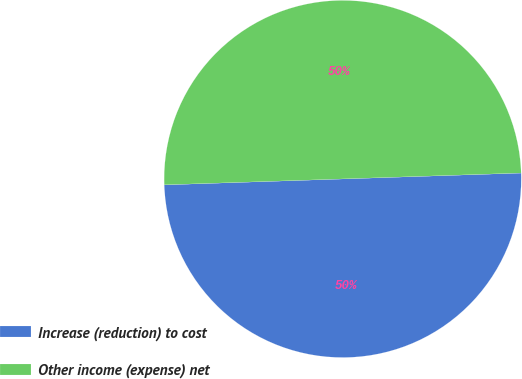Convert chart to OTSL. <chart><loc_0><loc_0><loc_500><loc_500><pie_chart><fcel>Increase (reduction) to cost<fcel>Other income (expense) net<nl><fcel>50.0%<fcel>50.0%<nl></chart> 